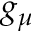Convert formula to latex. <formula><loc_0><loc_0><loc_500><loc_500>g _ { \mu }</formula> 